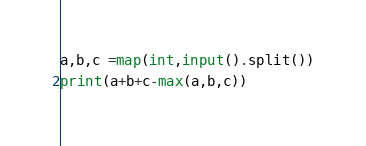Convert code to text. <code><loc_0><loc_0><loc_500><loc_500><_Python_>a,b,c =map(int,input().split())
print(a+b+c-max(a,b,c))</code> 